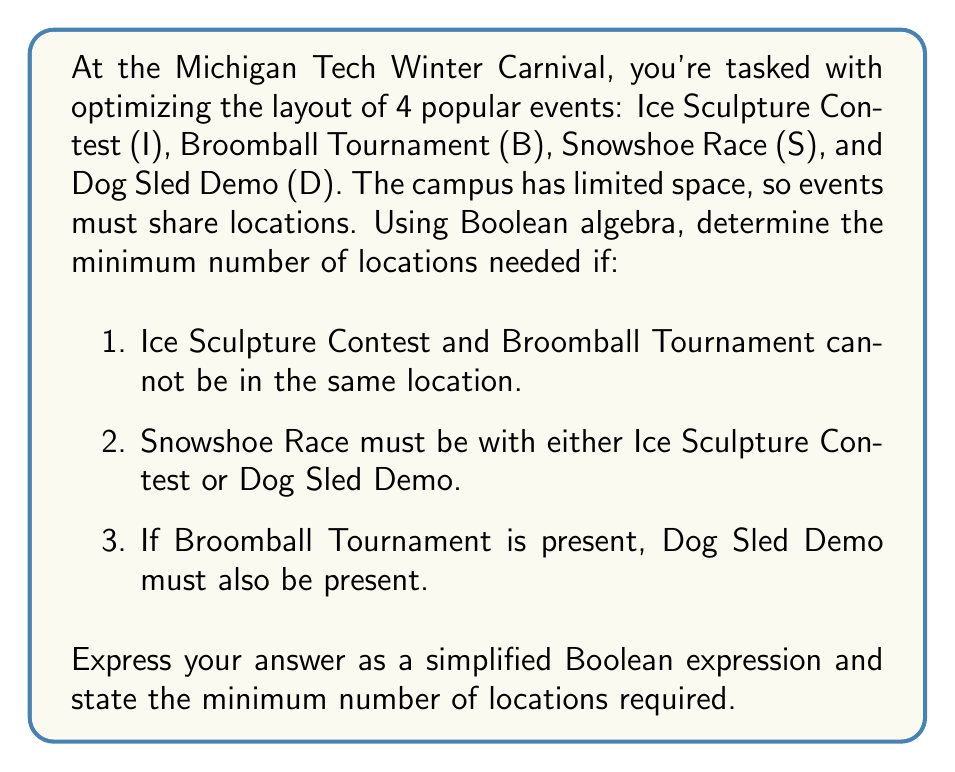Show me your answer to this math problem. Let's approach this step-by-step using Boolean algebra:

1) First, let's define our variables:
   I: Ice Sculpture Contest
   B: Broomball Tournament
   S: Snowshoe Race
   D: Dog Sled Demo

2) Now, let's translate the given conditions into Boolean expressions:
   a) I and B cannot be in the same location: $I \cdot B = 0$
   b) S must be with I or D: $S = S \cdot (I + D)$
   c) If B is present, D must be present: $B \leq D$ or $B + D' = 1$

3) To find the minimum number of locations, we need to find the minimum number of terms in the sum-of-products (SOP) form that satisfies all conditions.

4) Let's start with the full SOP expression:
   $IBSD + IBS'D + IB'SD + IB'S'D + I'BSD + I'BS'D + I'B'SD + I'B'S'D$

5) From condition (a), we can eliminate terms with both I and B:
   $IB'SD + IB'S'D + I'BSD + I'BS'D + I'B'SD + I'B'S'D$

6) From condition (b), we can eliminate terms where S is present but neither I nor D is:
   (This condition is already satisfied in our current expression)

7) From condition (c), we can eliminate terms where B is present but D is not:
   (This condition is also already satisfied)

8) Now, let's simplify:
   $IB'D(S + S') + I'BD(S + S') + I'B'S(D + D') + I'B'S'D$
   $= IB'D + I'BD + I'B'S + I'B'S'D$

9) This can't be simplified further without violating the given conditions.

Therefore, the minimum number of locations needed is 4, corresponding to the 4 terms in our final expression.
Answer: Simplified Boolean expression: $IB'D + I'BD + I'B'S + I'B'S'D$

Minimum number of locations required: 4 